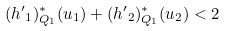Convert formula to latex. <formula><loc_0><loc_0><loc_500><loc_500>( { { h ^ { \prime } } _ { 1 } } ) _ { Q _ { 1 } } ^ { * } ( u _ { 1 } ) + ( { { h ^ { \prime } } _ { 2 } } ) _ { Q _ { 1 } } ^ { * } ( u _ { 2 } ) < 2</formula> 